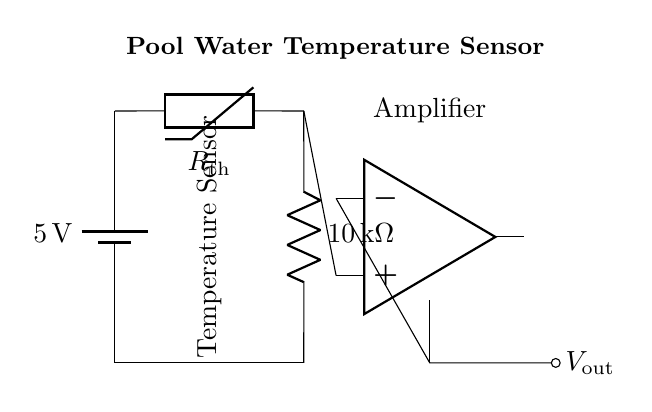What is the voltage of this circuit? The voltage of this circuit is 5 volts, which is shown at the battery connected at the top of the circuit diagram.
Answer: 5 volts What type of sensor is used in this circuit? The circuit uses a thermistor, as indicated by the label next to the component in the diagram.
Answer: Thermistor What is the resistance value of the resistor in the circuit? The resistance value of the resistor is 10 kilohms, which is specified next to the resistor symbol in the diagram.
Answer: 10 kilohms What does the operational amplifier do in this circuit? The operational amplifier, labeled "Amplifier" in the diagram, is used to amplify the voltage signal from the sensor for better readability and analysis.
Answer: Amplifies What is the output voltage connection labeled as? The output voltage connection is labeled as "Vout", which indicates where the amplified signal can be retrieved from the circuit.
Answer: Vout Why is the thermistor used for pool temperature sensing? A thermistor is chosen for temperature sensing because it has a resistance that changes significantly with temperature, allowing for precise monitoring of water conditions.
Answer: Precise monitoring 